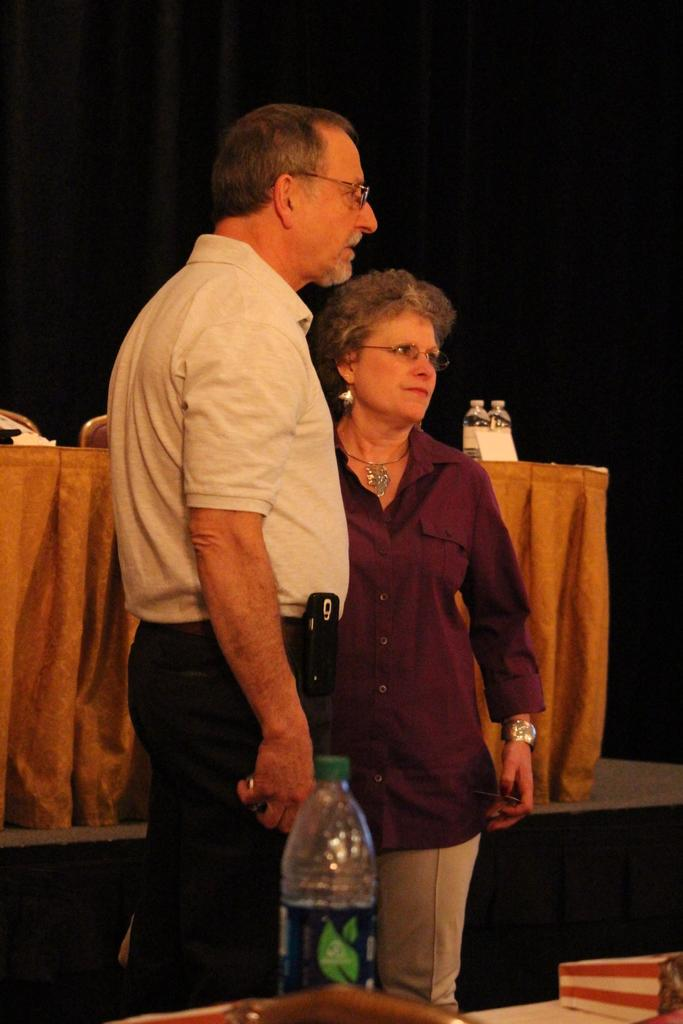How many people are in the image? There are two persons in the image. What is the man wearing? The man is wearing a white T-shirt. What can be seen at the bottom of the image? There is a table at the bottom of the image. What is on the table? A bottle is present on the table. What color is the background of the image? The background of the image is black. Is there steam coming from the bottle in the image? There is no steam visible in the image; it only shows a bottle on the table. 